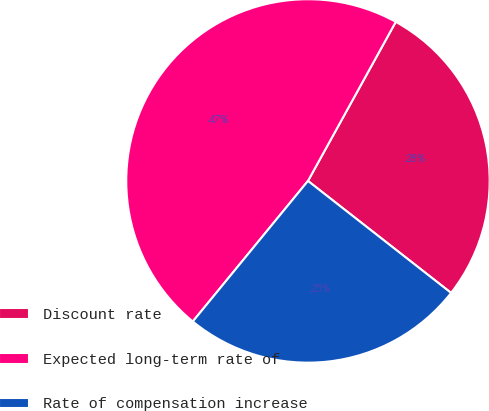Convert chart. <chart><loc_0><loc_0><loc_500><loc_500><pie_chart><fcel>Discount rate<fcel>Expected long-term rate of<fcel>Rate of compensation increase<nl><fcel>27.54%<fcel>47.1%<fcel>25.36%<nl></chart> 